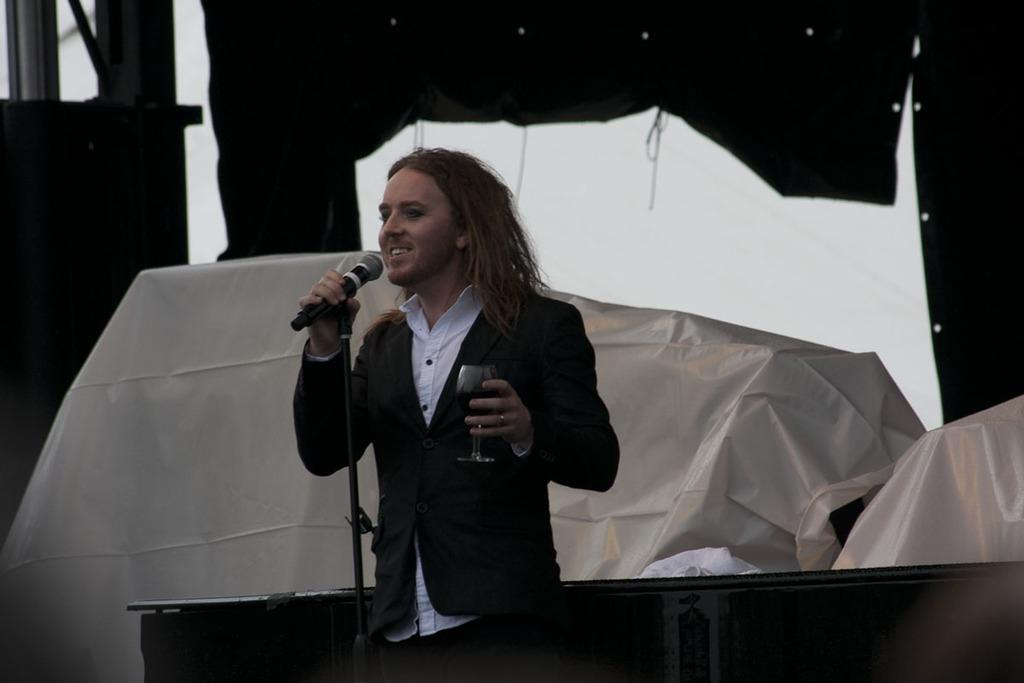What is the main subject of the image? There is a man in the image. What is the man doing in the image? The man is standing in the image. What objects is the man holding in the image? The man is holding a microphone and a glass of drink in the image. What is present in front of the man in the image? There is a microphone stand in front of the man in the image. What can be seen in the background of the image? There are covers visible in the background of the image. What type of card is the man using to play a game in the image? There is no card present in the image; the man is holding a microphone and a glass of drink. What kind of toy is the man playing with in the image? There is no toy present in the image; the man is holding a microphone and a glass of drink. 